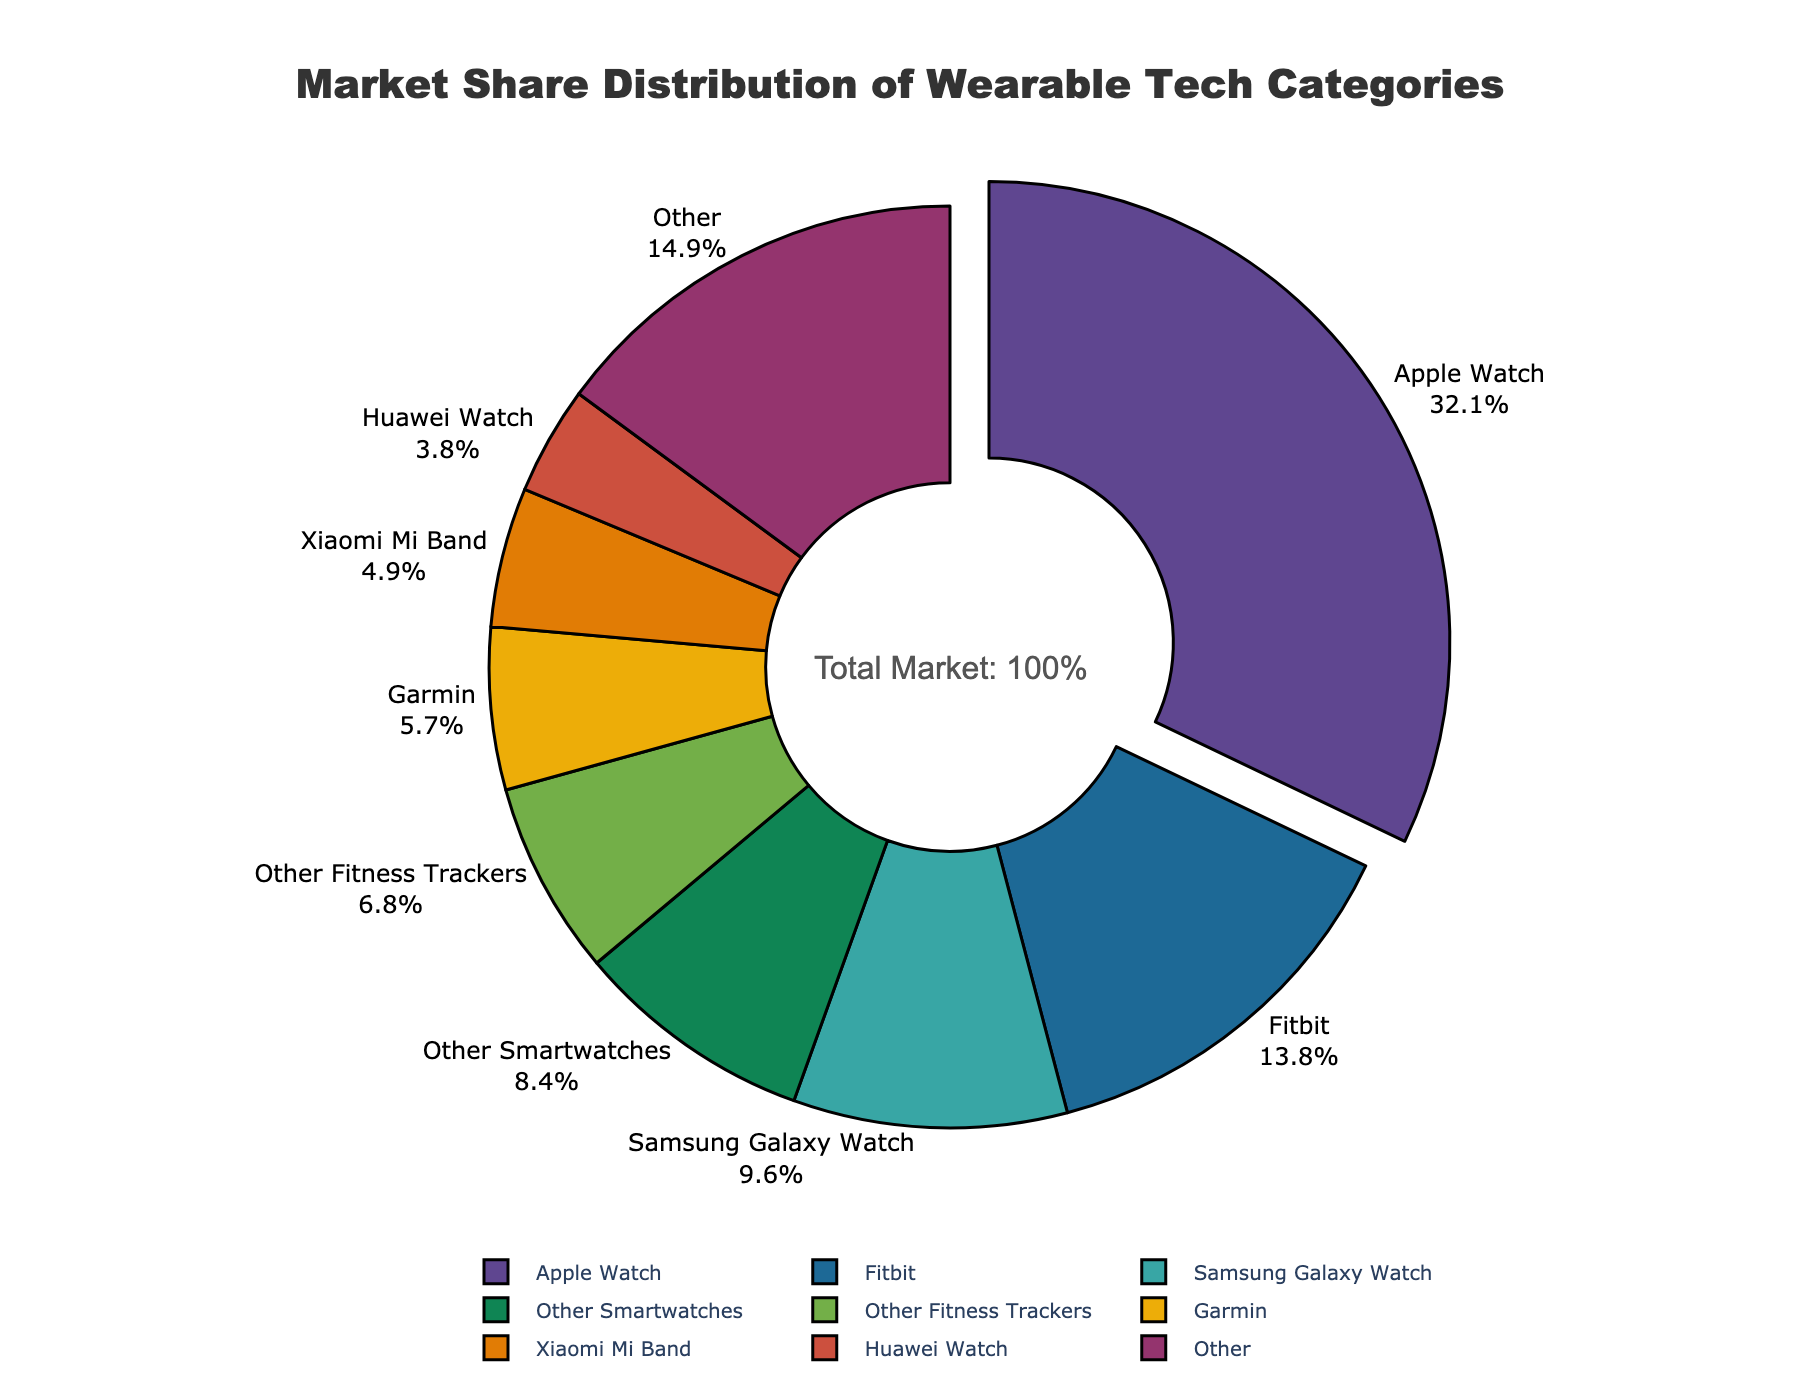What's the market share of Apple Watch compared to Fitbit? The pie chart shows the percentage of market share for each category, with text labels displaying the percentages. The Apple Watch has a market share of 32.1%, while Fitbit has a market share of 13.8%.
Answer: Apple Watch: 32.1%, Fitbit: 13.8% How much larger is the market share of Apple Watch than Samsung Galaxy Watch? The Apple Watch has a market share of 32.1%, and the Samsung Galaxy Watch has a market share of 9.6%. The difference can be calculated by subtracting Samsung's share from Apple's share: 32.1% - 9.6% = 22.5%.
Answer: 22.5% What is the combined market share of Garmin and Xiaomi Mi Band? Garmin has a market share of 5.7% and Xiaomi Mi Band has 4.9%. Adding these together gives: 5.7% + 4.9% = 10.6%.
Answer: 10.6% Which category in the pie chart has the lowest market share, and what is its value? The pie chart labels show the market shares. The smallest market share is for TicWatch, which has a share of 1.2%.
Answer: TicWatch, 1.2% What is the combined market share of "Other" categories? The "Other" category combines smaller categories listed in the data. The pie chart shows that the "Other" category (combined from smaller shares) has a market share, which is the sum of shares less than the top categories. This is displayed in the pie chart.
Answer: see pie chart Which category is highlighted by being pulled out from the center of the pie chart? The visual cue in the pie chart shows that the category pulled out from the center is the Apple Watch, emphasizing its importance.
Answer: Apple Watch How many categories have a market share greater than or equal to 4.0%? From the pie chart, the categories with market shares greater than or equal to 4.0% are Apple Watch, Fitbit, Samsung Galaxy Watch, Garmin, and Xiaomi Mi Band. Counting these gives us 5 categories.
Answer: 5 What is the average market share of the categories Fitbit, Samsung Galaxy Watch, and Garmin? The market shares for Fitbit, Samsung Galaxy Watch, and Garmin are 13.8%, 9.6%, and 5.7% respectively. To find the average, sum these values and divide by 3: (13.8% + 9.6% + 5.7%) / 3 ≈ 9.7%.
Answer: 9.7% What proportion of the market share does the top category (Apple Watch) represent of the total market? The pie chart indicates that the total market share is 100%. The Apple Watch alone holds 32.1%, so the proportion is simply 32.1% of the total market.
Answer: 32.1% Comparing Amazfit and Google Pixel Watch, which has a higher market share, and by how much? According to the pie chart, Amazfit has a market share of 2.5% and Google Pixel Watch has a share of 2.2%. The difference is found by subtracting the smaller share from the larger share: 2.5% - 2.2% = 0.3%.
Answer: Amazfit by 0.3% 